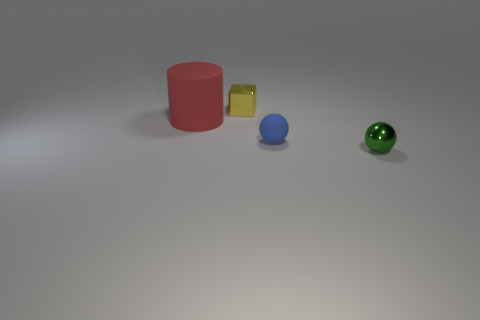Is there any other thing that has the same size as the red cylinder?
Offer a very short reply. No. What shape is the shiny object that is in front of the rubber thing on the left side of the yellow block?
Your response must be concise. Sphere. Are there fewer small brown matte cubes than blue rubber spheres?
Provide a short and direct response. Yes. What is the size of the object that is in front of the small yellow cube and on the left side of the tiny blue rubber ball?
Provide a succinct answer. Large. Is the blue rubber object the same size as the yellow object?
Ensure brevity in your answer.  Yes. What number of small shiny objects are to the left of the large red object?
Provide a succinct answer. 0. Are there more large green shiny spheres than blue rubber spheres?
Ensure brevity in your answer.  No. What shape is the small object that is left of the small green shiny sphere and right of the tiny yellow shiny cube?
Your answer should be compact. Sphere. Is there a large blue cylinder?
Offer a terse response. No. What is the material of the other object that is the same shape as the blue object?
Your response must be concise. Metal. 